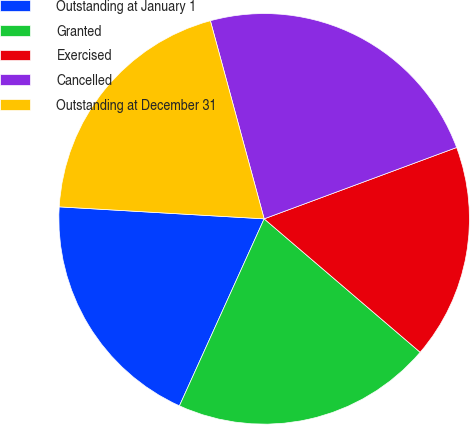Convert chart. <chart><loc_0><loc_0><loc_500><loc_500><pie_chart><fcel>Outstanding at January 1<fcel>Granted<fcel>Exercised<fcel>Cancelled<fcel>Outstanding at December 31<nl><fcel>19.16%<fcel>20.51%<fcel>16.91%<fcel>23.57%<fcel>19.85%<nl></chart> 